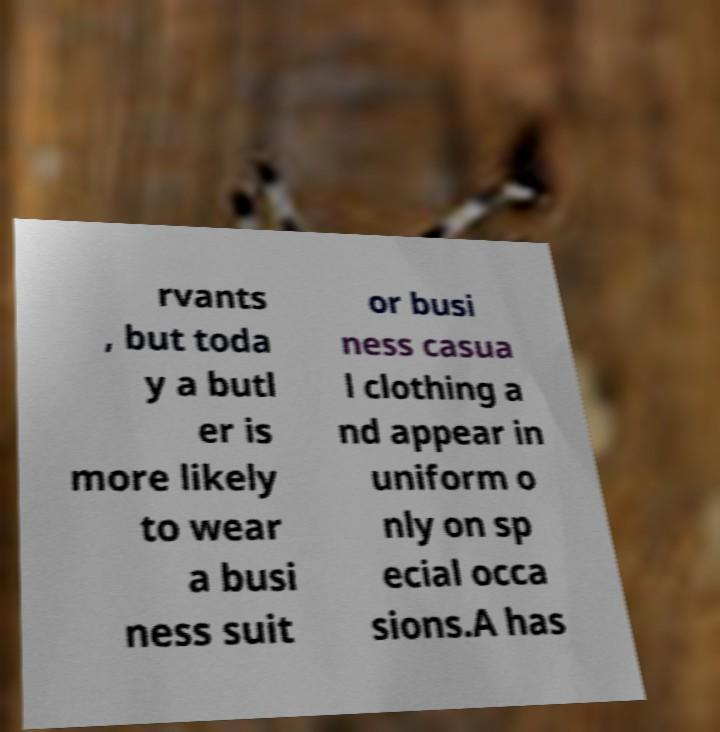There's text embedded in this image that I need extracted. Can you transcribe it verbatim? rvants , but toda y a butl er is more likely to wear a busi ness suit or busi ness casua l clothing a nd appear in uniform o nly on sp ecial occa sions.A has 